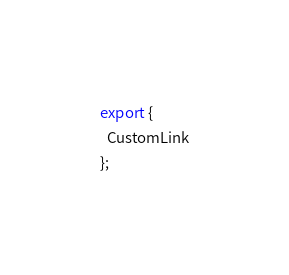Convert code to text. <code><loc_0><loc_0><loc_500><loc_500><_TypeScript_>export {
  CustomLink
};
</code> 